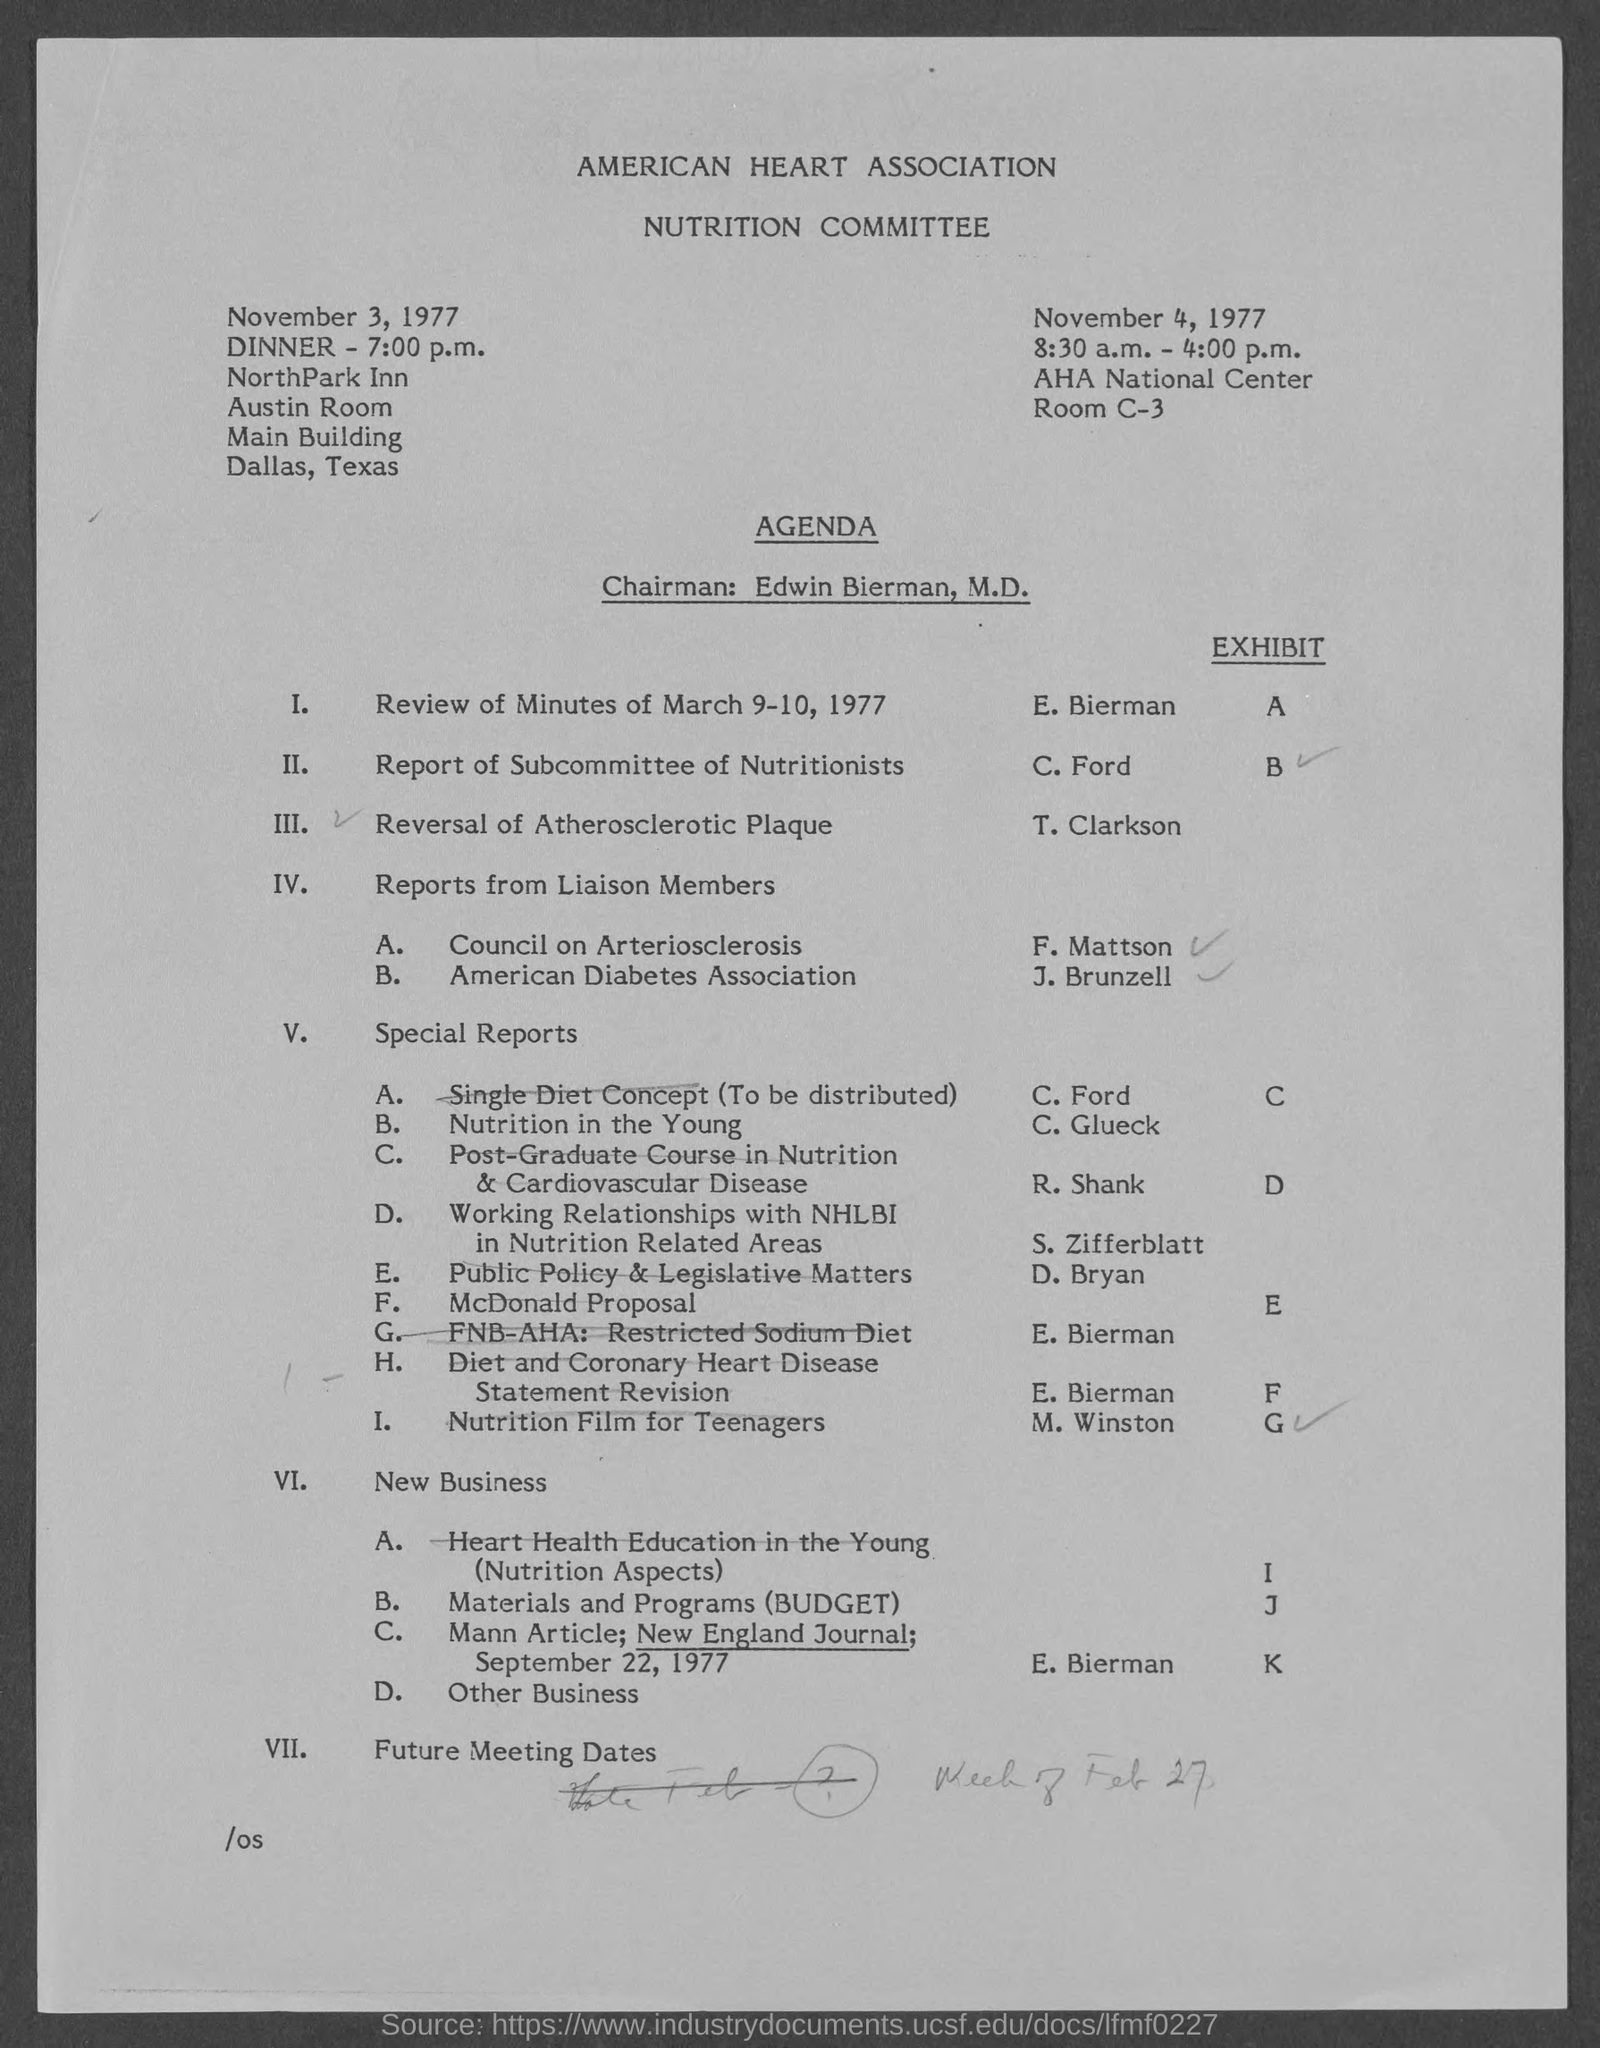Where is the dinner held?
Provide a succinct answer. NorthPark Inn. Who is the Chairman?
Ensure brevity in your answer.  Edwin Bierman, M.D. Where is the meeting on November 4, 1977?
Give a very brief answer. AHA National Center Room C-3. 